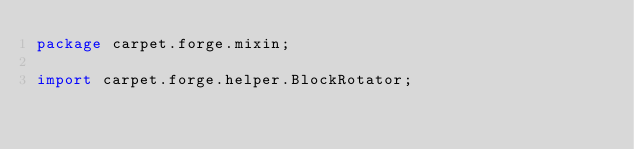Convert code to text. <code><loc_0><loc_0><loc_500><loc_500><_Java_>package carpet.forge.mixin;

import carpet.forge.helper.BlockRotator;</code> 